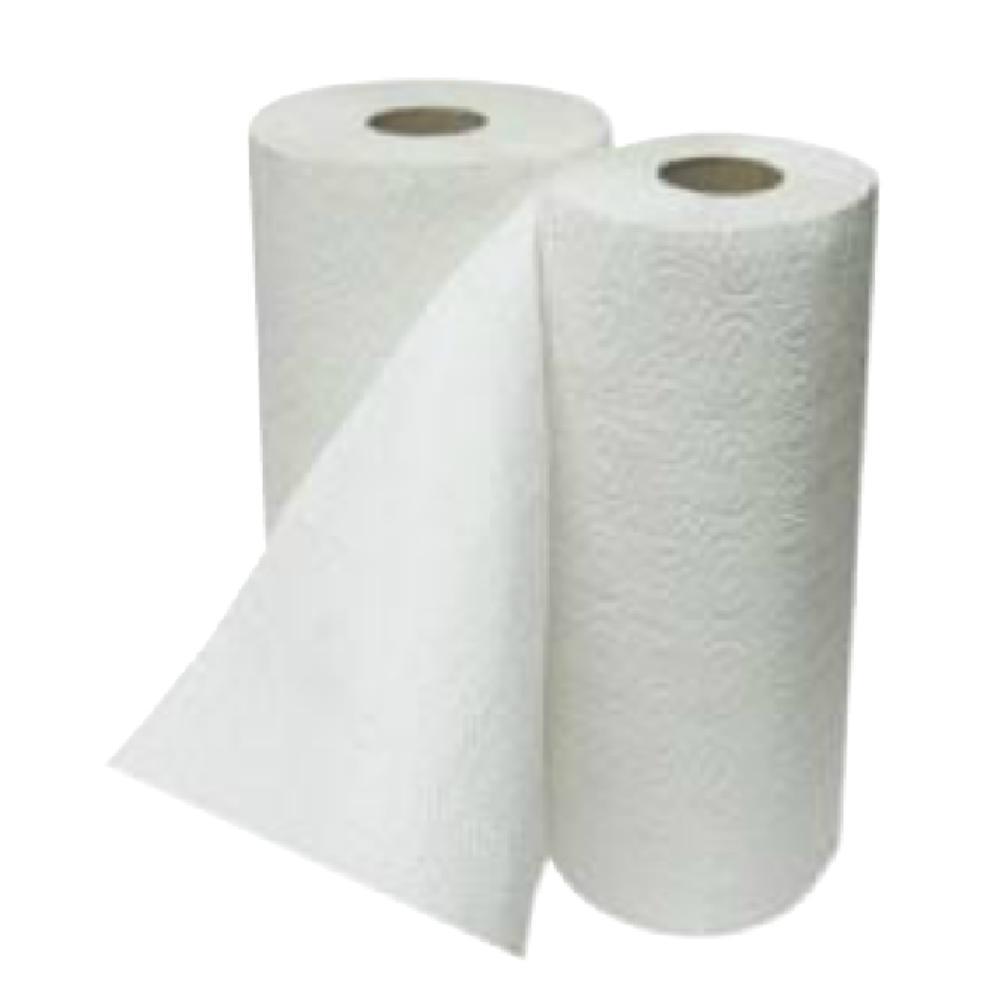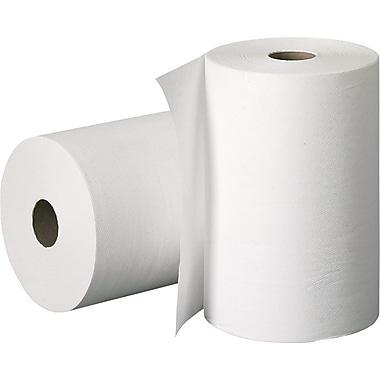The first image is the image on the left, the second image is the image on the right. Assess this claim about the two images: "A towel roll is held vertically on a stand with a silver base.". Correct or not? Answer yes or no. No. 